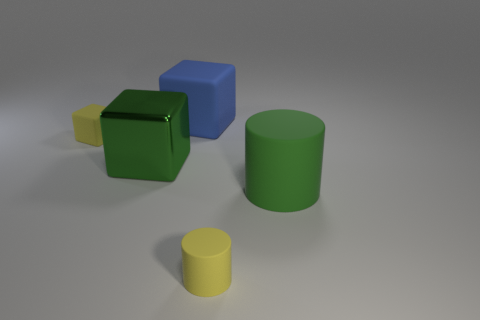There is a rubber cylinder in front of the big green cylinder that is behind the yellow rubber cylinder; what color is it?
Your response must be concise. Yellow. What is the size of the object that is both behind the tiny matte cylinder and right of the blue rubber cube?
Keep it short and to the point. Large. Is there any other thing of the same color as the large matte block?
Offer a terse response. No. There is a yellow object that is the same material as the tiny cube; what shape is it?
Your answer should be very brief. Cylinder. There is a big green matte thing; is it the same shape as the yellow object that is on the right side of the yellow rubber block?
Make the answer very short. Yes. There is a large cube that is in front of the tiny yellow thing behind the large matte cylinder; what is its material?
Give a very brief answer. Metal. Are there the same number of tiny yellow rubber cubes left of the yellow cylinder and blue things?
Your answer should be compact. Yes. Is there any other thing that is the same material as the green cube?
Provide a short and direct response. No. Is the color of the small rubber object behind the large rubber cylinder the same as the cylinder that is in front of the big green matte object?
Ensure brevity in your answer.  Yes. How many yellow objects are to the right of the big rubber block and to the left of the large blue rubber object?
Make the answer very short. 0. 